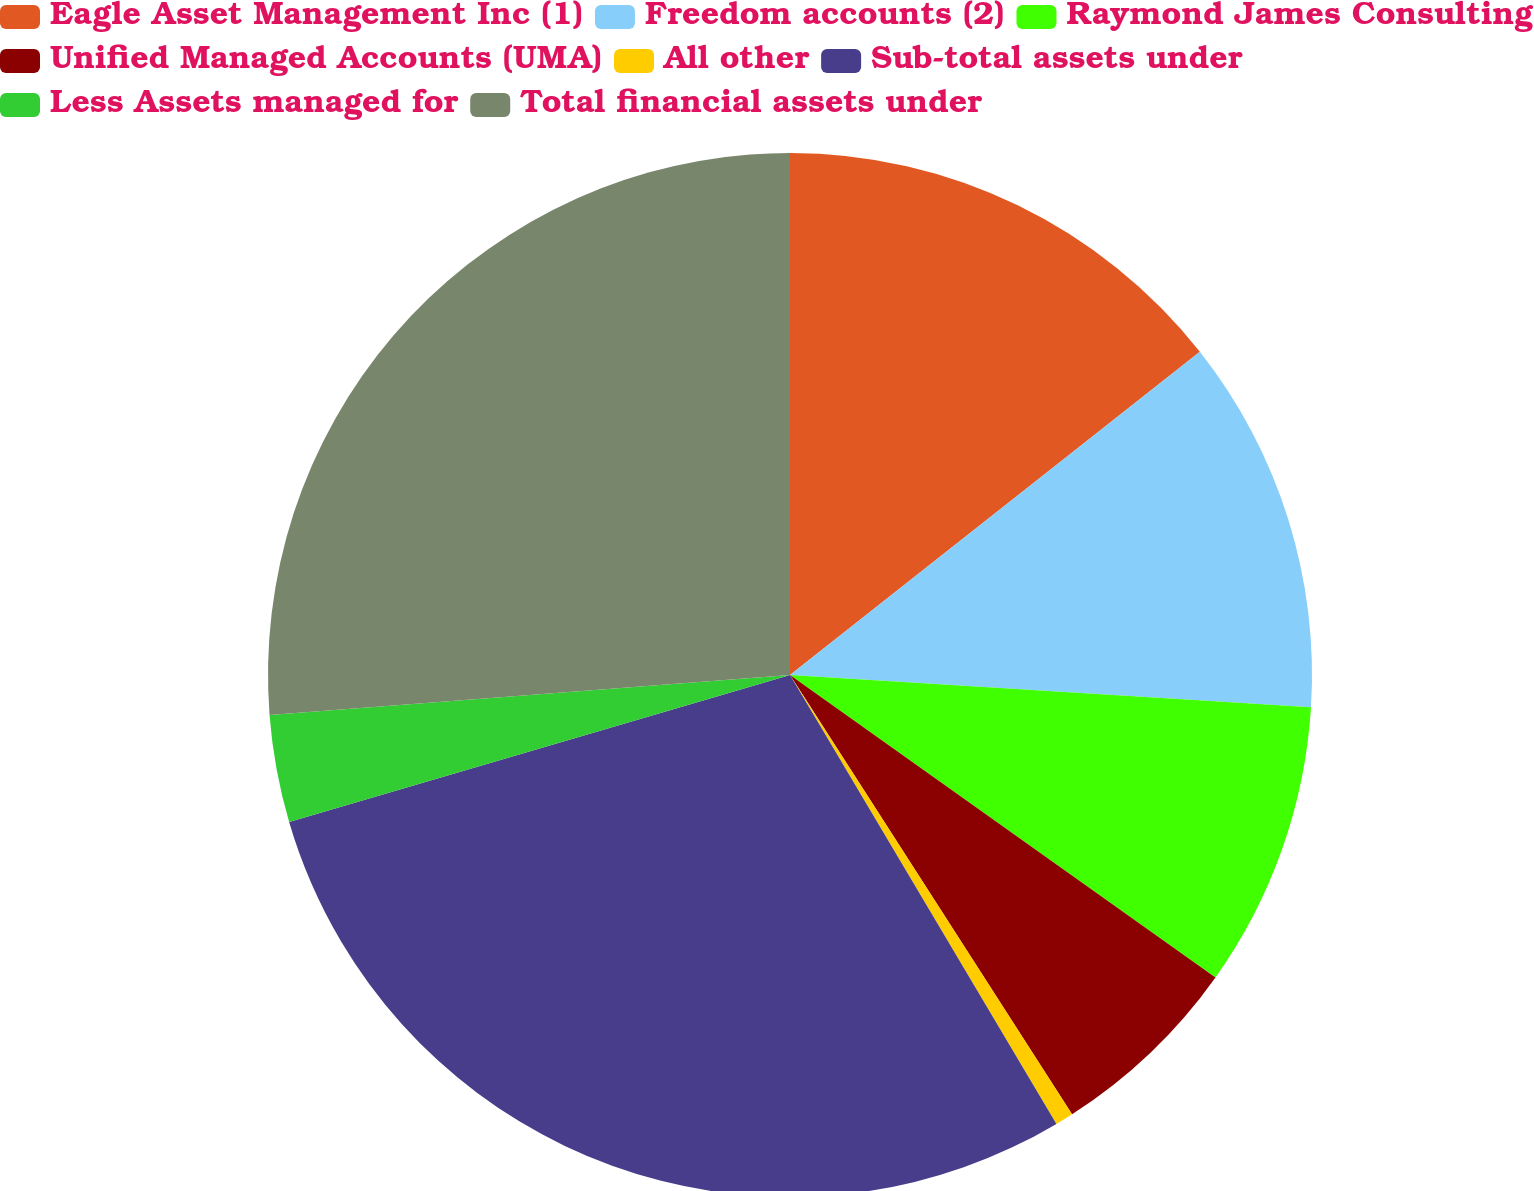Convert chart to OTSL. <chart><loc_0><loc_0><loc_500><loc_500><pie_chart><fcel>Eagle Asset Management Inc (1)<fcel>Freedom accounts (2)<fcel>Raymond James Consulting<fcel>Unified Managed Accounts (UMA)<fcel>All other<fcel>Sub-total assets under<fcel>Less Assets managed for<fcel>Total financial assets under<nl><fcel>14.37%<fcel>11.61%<fcel>8.85%<fcel>6.08%<fcel>0.56%<fcel>28.98%<fcel>3.32%<fcel>26.22%<nl></chart> 